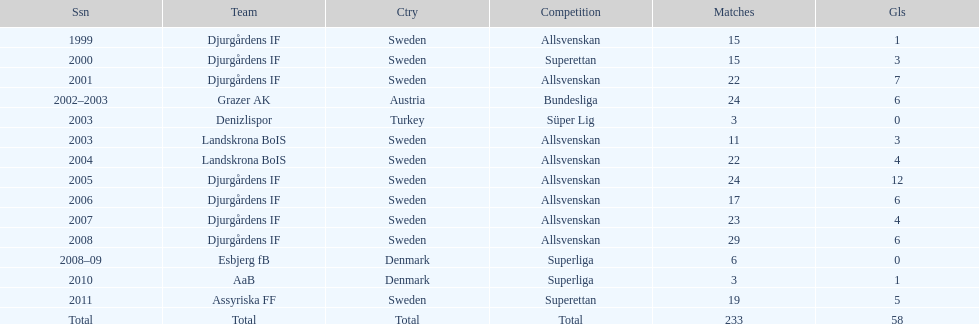How many matches did jones kusi-asare play in in his first season? 15. Parse the full table. {'header': ['Ssn', 'Team', 'Ctry', 'Competition', 'Matches', 'Gls'], 'rows': [['1999', 'Djurgårdens IF', 'Sweden', 'Allsvenskan', '15', '1'], ['2000', 'Djurgårdens IF', 'Sweden', 'Superettan', '15', '3'], ['2001', 'Djurgårdens IF', 'Sweden', 'Allsvenskan', '22', '7'], ['2002–2003', 'Grazer AK', 'Austria', 'Bundesliga', '24', '6'], ['2003', 'Denizlispor', 'Turkey', 'Süper Lig', '3', '0'], ['2003', 'Landskrona BoIS', 'Sweden', 'Allsvenskan', '11', '3'], ['2004', 'Landskrona BoIS', 'Sweden', 'Allsvenskan', '22', '4'], ['2005', 'Djurgårdens IF', 'Sweden', 'Allsvenskan', '24', '12'], ['2006', 'Djurgårdens IF', 'Sweden', 'Allsvenskan', '17', '6'], ['2007', 'Djurgårdens IF', 'Sweden', 'Allsvenskan', '23', '4'], ['2008', 'Djurgårdens IF', 'Sweden', 'Allsvenskan', '29', '6'], ['2008–09', 'Esbjerg fB', 'Denmark', 'Superliga', '6', '0'], ['2010', 'AaB', 'Denmark', 'Superliga', '3', '1'], ['2011', 'Assyriska FF', 'Sweden', 'Superettan', '19', '5'], ['Total', 'Total', 'Total', 'Total', '233', '58']]} 